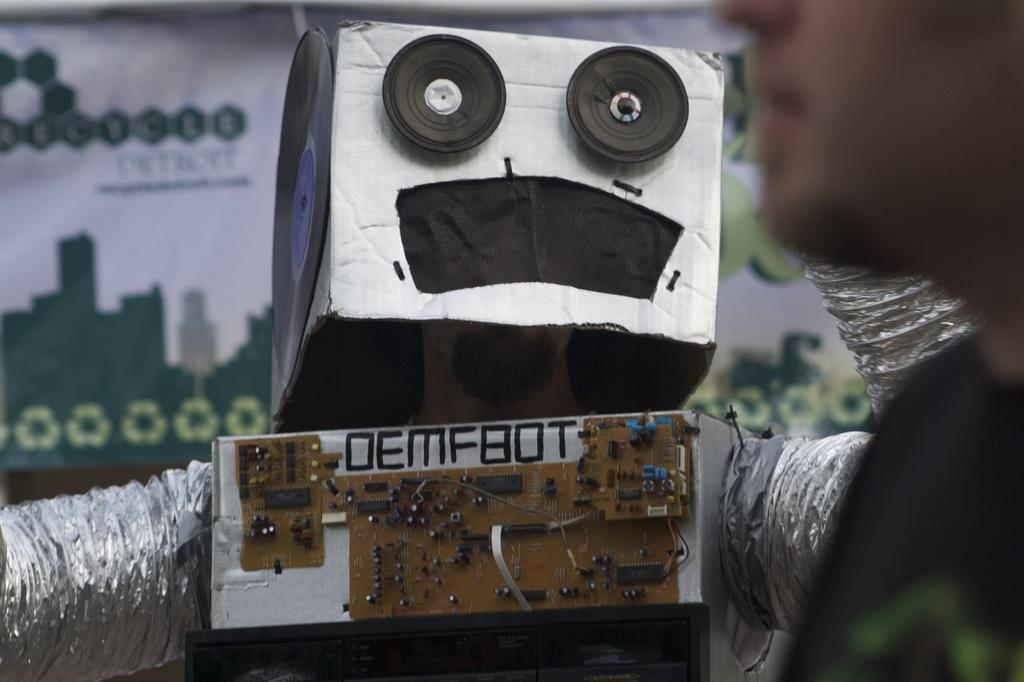Who or what is on the right side of the image? There is a person on the right side of the image. What is located behind the person? There is a robot behind the person. What is visible behind the robot? There is a banner behind the robot. How does the person measure the brass in the image? There is no brass present in the image, and the person is not measuring anything. 